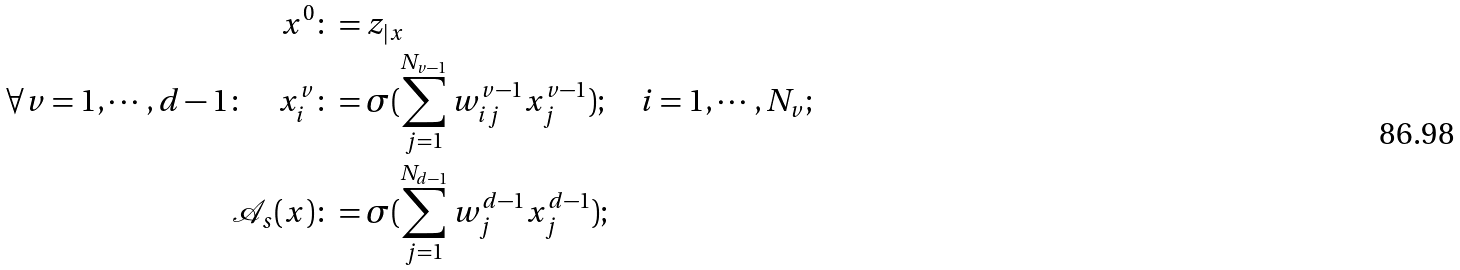<formula> <loc_0><loc_0><loc_500><loc_500>x ^ { 0 } & \colon = z _ { | x } \\ \forall v = 1 , \cdots , d - 1 \colon \quad x ^ { v } _ { i } & \colon = \sigma ( \sum _ { j = 1 } ^ { N _ { v - 1 } } w ^ { v - 1 } _ { i j } x ^ { v - 1 } _ { j } ) ; \quad i = 1 , \cdots , N _ { v } ; \\ \mathcal { A } _ { s } ( x ) & \colon = \sigma ( \sum _ { j = 1 } ^ { N _ { d - 1 } } w ^ { d - 1 } _ { j } x ^ { d - 1 } _ { j } ) ;</formula> 